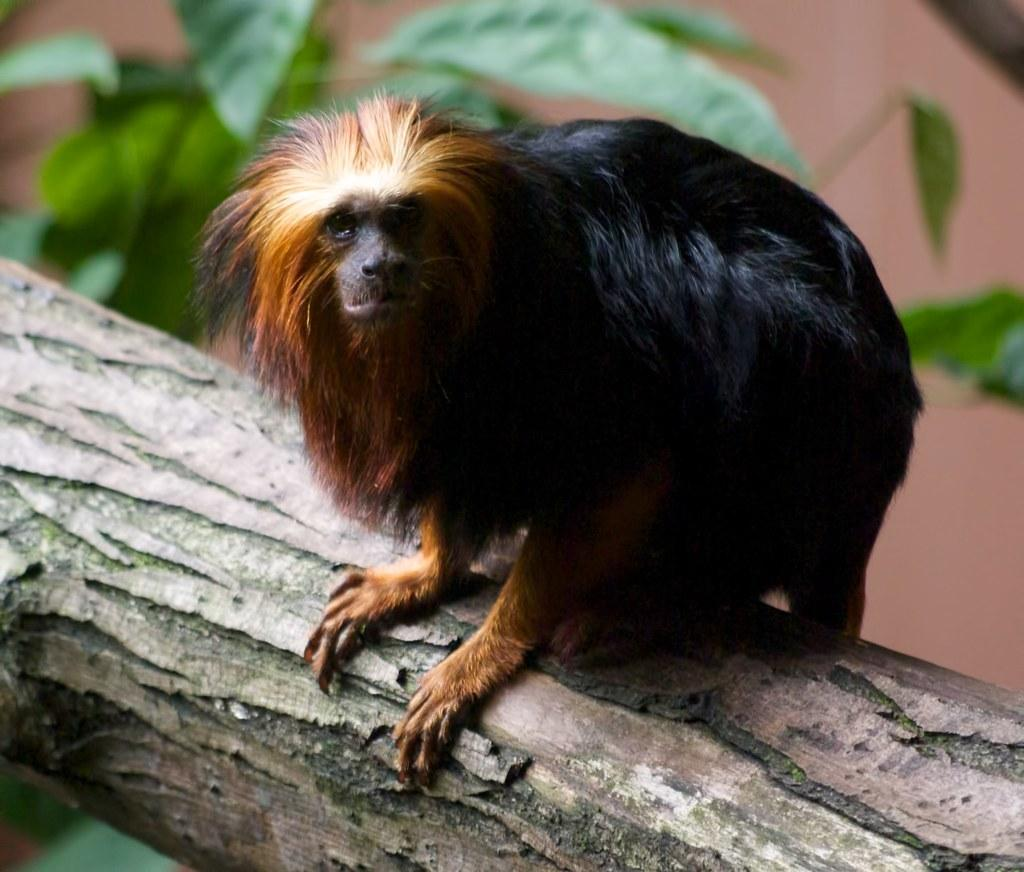What type of animal is in the image? There is a golden lion tamarin in the image. Where is the golden lion tamarin located? The golden lion tamarin is on a tree trunk. What can be seen in the background of the image? The background of the image has a blurred view. What color are the leaves visible in the image? The leaves visible in the image are green. What type of soup is being served in the image? There is no soup present in the image; it features a golden lion tamarin on a tree trunk. Can you see any sand in the image? There is no sand visible in the image. 